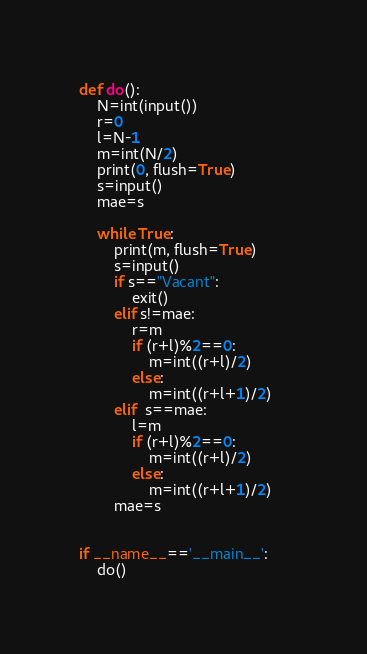Convert code to text. <code><loc_0><loc_0><loc_500><loc_500><_Python_>def do():
    N=int(input())
    r=0
    l=N-1
    m=int(N/2)
    print(0, flush=True)
    s=input()
    mae=s

    while True: 
        print(m, flush=True)       
        s=input()
        if s=="Vacant":
            exit()
        elif s!=mae:
            r=m
            if (r+l)%2==0:
                m=int((r+l)/2)
            else:
                m=int((r+l+1)/2)
        elif  s==mae:
            l=m
            if (r+l)%2==0:
                m=int((r+l)/2)
            else:
                m=int((r+l+1)/2)
        mae=s
    

if __name__=='__main__':
    do()
</code> 